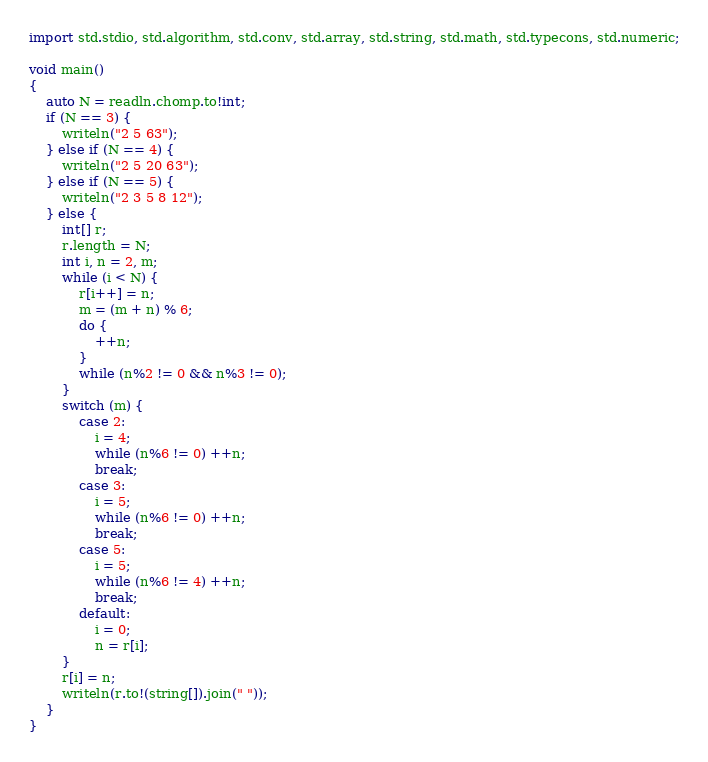<code> <loc_0><loc_0><loc_500><loc_500><_D_>import std.stdio, std.algorithm, std.conv, std.array, std.string, std.math, std.typecons, std.numeric;

void main()
{
    auto N = readln.chomp.to!int;
    if (N == 3) {
        writeln("2 5 63");
    } else if (N == 4) {
        writeln("2 5 20 63");
    } else if (N == 5) {
        writeln("2 3 5 8 12");
    } else {
        int[] r;
        r.length = N;
        int i, n = 2, m;
        while (i < N) {
            r[i++] = n;
            m = (m + n) % 6;
            do {
                ++n;
            }
            while (n%2 != 0 && n%3 != 0);
        }
        switch (m) {
            case 2:
                i = 4;
                while (n%6 != 0) ++n;
                break;
            case 3:
                i = 5;
                while (n%6 != 0) ++n;
                break;
            case 5:
                i = 5;
                while (n%6 != 4) ++n;
                break;
            default:
                i = 0;
                n = r[i];
        }
        r[i] = n;
        writeln(r.to!(string[]).join(" "));
    }
}</code> 